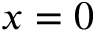Convert formula to latex. <formula><loc_0><loc_0><loc_500><loc_500>x = 0</formula> 